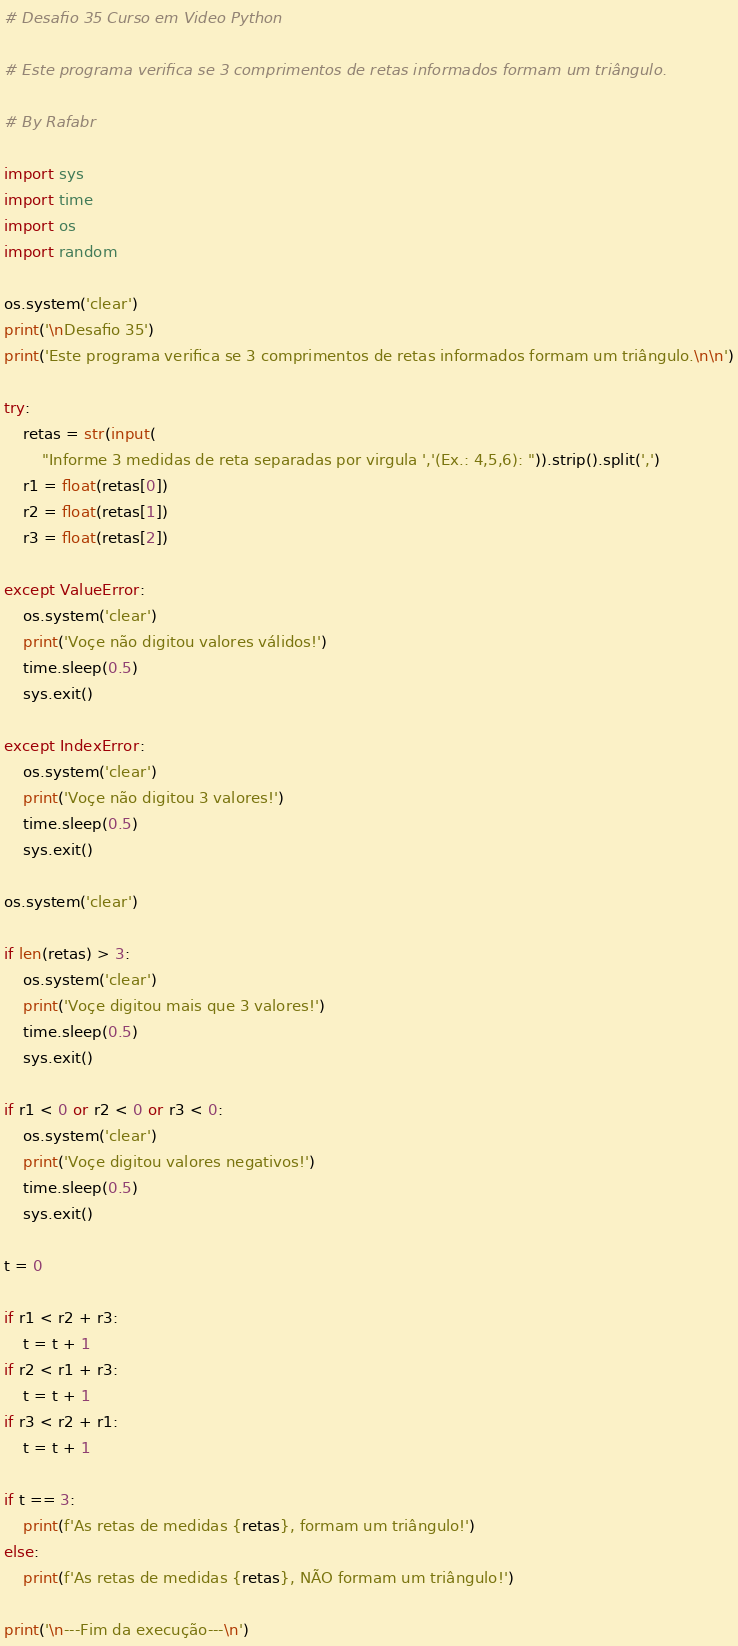<code> <loc_0><loc_0><loc_500><loc_500><_Python_># Desafio 35 Curso em Video Python

# Este programa verifica se 3 comprimentos de retas informados formam um triângulo.

# By Rafabr

import sys
import time
import os
import random

os.system('clear')
print('\nDesafio 35')
print('Este programa verifica se 3 comprimentos de retas informados formam um triângulo.\n\n')

try:
    retas = str(input(
        "Informe 3 medidas de reta separadas por virgula ','(Ex.: 4,5,6): ")).strip().split(',')
    r1 = float(retas[0])
    r2 = float(retas[1])
    r3 = float(retas[2])

except ValueError:
    os.system('clear')
    print('Voçe não digitou valores válidos!')
    time.sleep(0.5)
    sys.exit()

except IndexError:
    os.system('clear')
    print('Voçe não digitou 3 valores!')
    time.sleep(0.5)
    sys.exit()

os.system('clear')

if len(retas) > 3:
    os.system('clear')
    print('Voçe digitou mais que 3 valores!')
    time.sleep(0.5)
    sys.exit()

if r1 < 0 or r2 < 0 or r3 < 0:
    os.system('clear')
    print('Voçe digitou valores negativos!')
    time.sleep(0.5)
    sys.exit()

t = 0

if r1 < r2 + r3:
    t = t + 1
if r2 < r1 + r3:
    t = t + 1
if r3 < r2 + r1:
    t = t + 1

if t == 3:
    print(f'As retas de medidas {retas}, formam um triângulo!')
else:
    print(f'As retas de medidas {retas}, NÃO formam um triângulo!')

print('\n---Fim da execução---\n')
</code> 